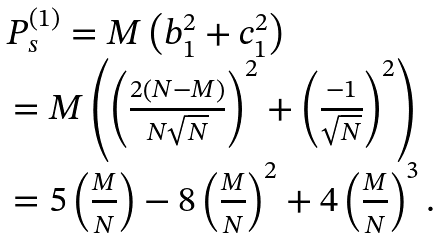<formula> <loc_0><loc_0><loc_500><loc_500>\begin{array} { l } P _ { s } ^ { ( 1 ) } = M \left ( { b _ { 1 } ^ { 2 } + c _ { 1 } ^ { 2 } } \right ) \\ \, = M \left ( { \left ( { \frac { { 2 \left ( { N - M } \right ) } } { N \sqrt { N } } } \right ) ^ { 2 } + \left ( { \frac { - 1 } { \sqrt { N } } } \right ) ^ { 2 } } \right ) \\ \, = 5 \left ( { \frac { M } { N } } \right ) - 8 \left ( { \frac { M } { N } } \right ) ^ { 2 } + 4 \left ( { \frac { M } { N } } \right ) ^ { 3 } . \\ \end{array}</formula> 